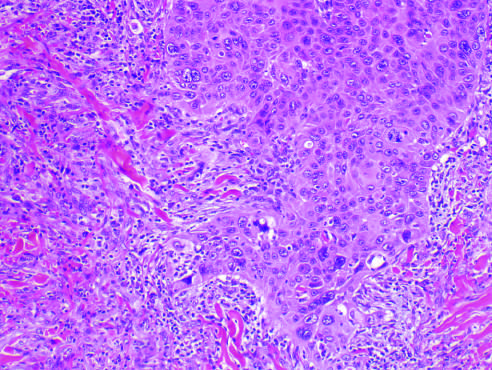does gross examination of a resected sigmoid colon invade the dermal soft tissue as irregular projections of atypical squamous cells exhibiting acantholysis?
Answer the question using a single word or phrase. No 